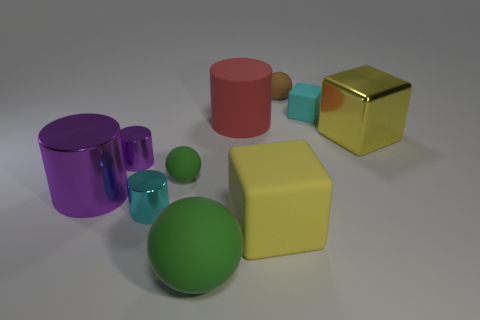What is the shape of the rubber object that is the same color as the large ball? The rubber object sharing the same color as the large ball is spherical in shape, much like the ball itself, hinting at a visual and conceptual symmetry between the two objects. 